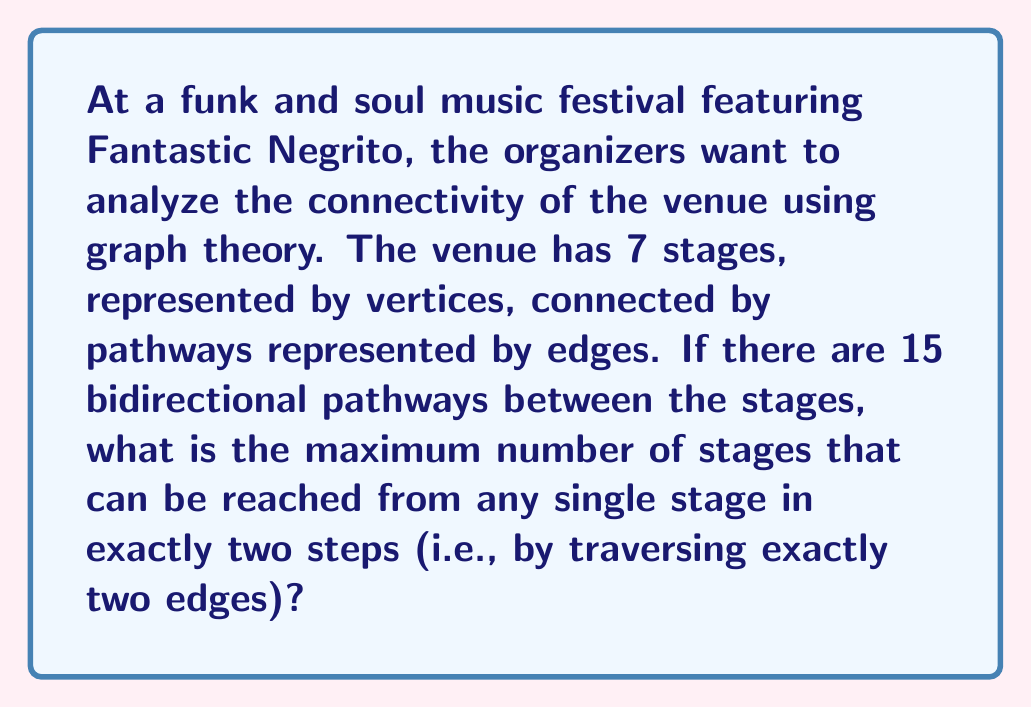What is the answer to this math problem? Let's approach this step-by-step using graph theory:

1) First, we need to understand what the question is asking. We're looking for the maximum number of vertices that can be reached in exactly two edges from any single vertex in a graph with 7 vertices and 15 edges.

2) The maximum number of stages reachable in two steps will occur when one stage is connected to as many other stages as possible, and those stages are in turn connected to as many unique stages as possible.

3) In an undirected graph with 7 vertices, the maximum degree of any vertex (i.e., the maximum number of edges connected to any single vertex) is 6.

4) Let's assume we have a vertex with the maximum degree of 6. We now need to calculate how many unique vertices these 6 neighbors can connect to in one more step.

5) The ideal scenario would be if each of these 6 neighbors could connect to a unique vertex. However, we only have 7 vertices in total, and we've already used 7 (the original vertex and its 6 neighbors).

6) This means that in the second step, we can at most reach the same 6 vertices we reached in the first step, plus potentially some of the vertices we've already counted (including possibly returning to the starting vertex).

7) Therefore, the maximum number of unique vertices reachable in exactly two steps is 6.

8) It's worth noting that this maximum is achievable in this graph. With 15 edges and 7 vertices, we have enough edges to create this configuration.

This analysis aligns well with the festival scenario, where a central stage (like where Fantastic Negrito might perform) could be connected to 6 other stages, maximizing the venue's connectivity.
Answer: 6 stages 